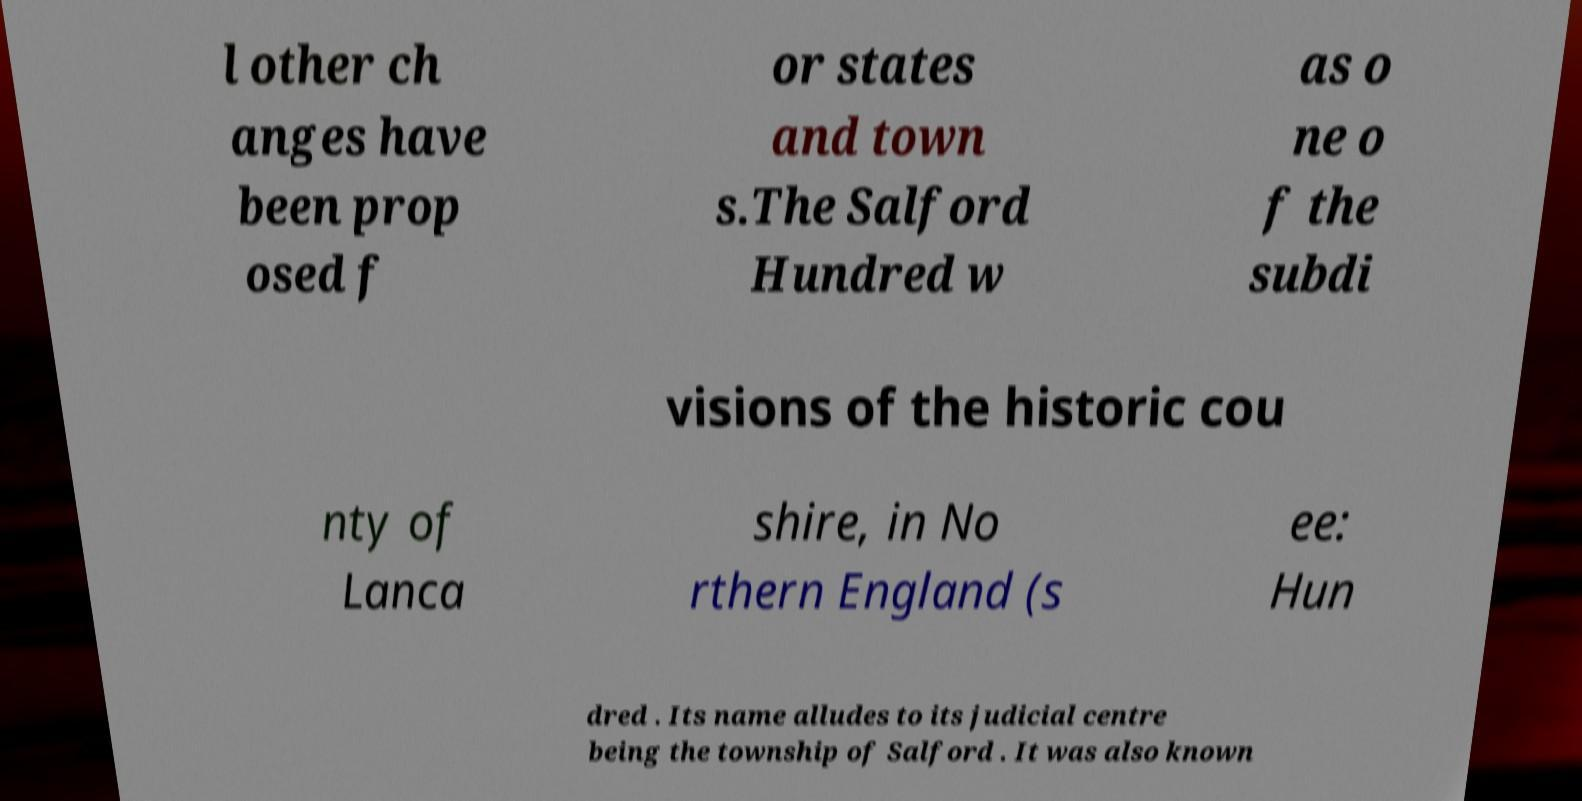There's text embedded in this image that I need extracted. Can you transcribe it verbatim? l other ch anges have been prop osed f or states and town s.The Salford Hundred w as o ne o f the subdi visions of the historic cou nty of Lanca shire, in No rthern England (s ee: Hun dred . Its name alludes to its judicial centre being the township of Salford . It was also known 